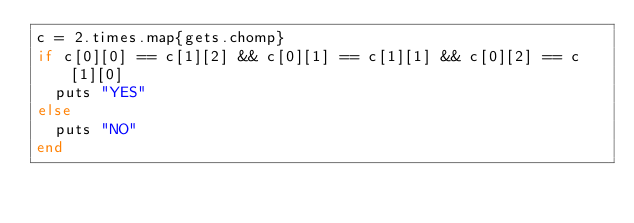<code> <loc_0><loc_0><loc_500><loc_500><_Ruby_>c = 2.times.map{gets.chomp}
if c[0][0] == c[1][2] && c[0][1] == c[1][1] && c[0][2] == c[1][0]
  puts "YES"
else
  puts "NO"
end</code> 